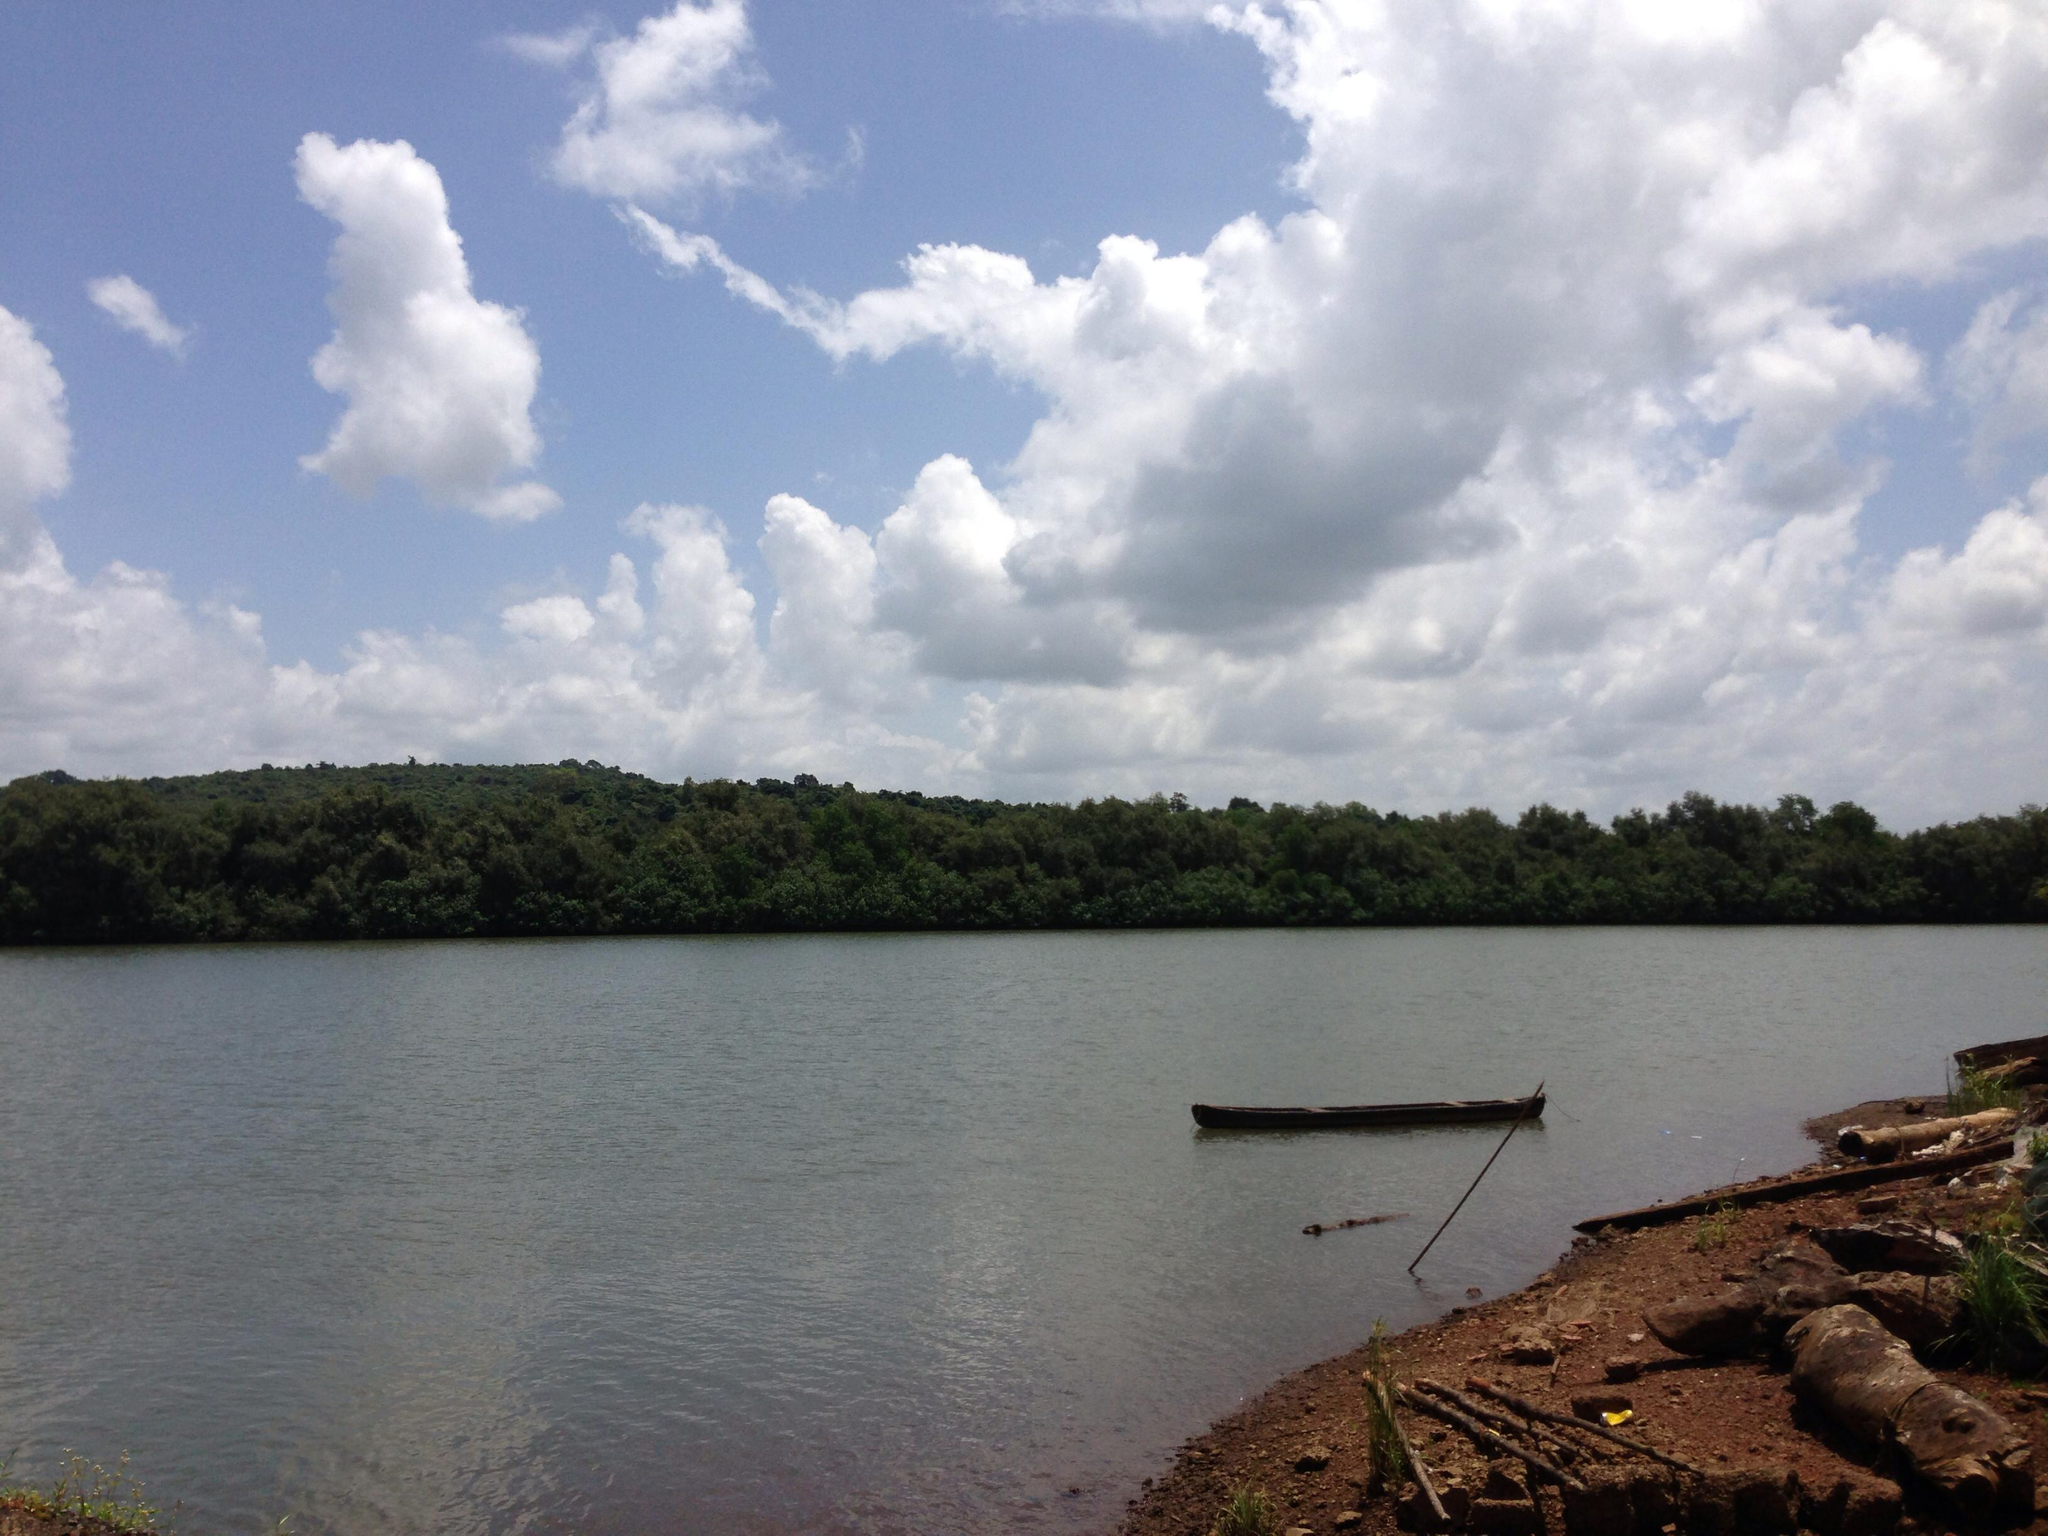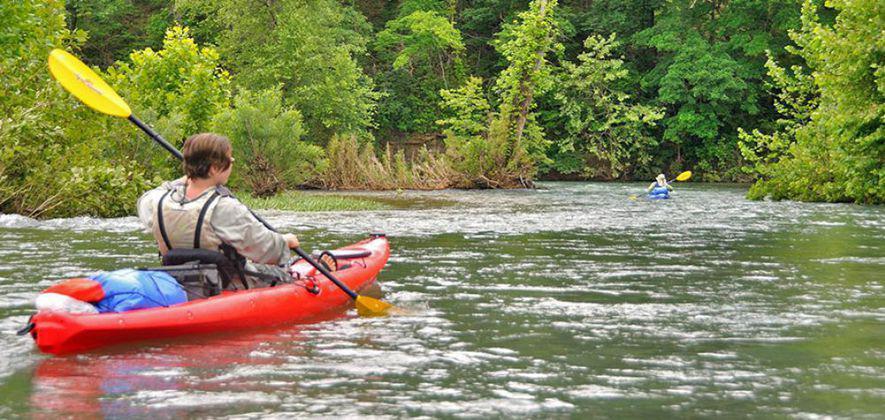The first image is the image on the left, the second image is the image on the right. Considering the images on both sides, is "In one image, three people, two of them using or sitting near oars, can be seen in a single canoe in a body of water near a shoreline with trees," valid? Answer yes or no. No. The first image is the image on the left, the second image is the image on the right. For the images shown, is this caption "An image includes three people in one canoe on the water." true? Answer yes or no. No. 